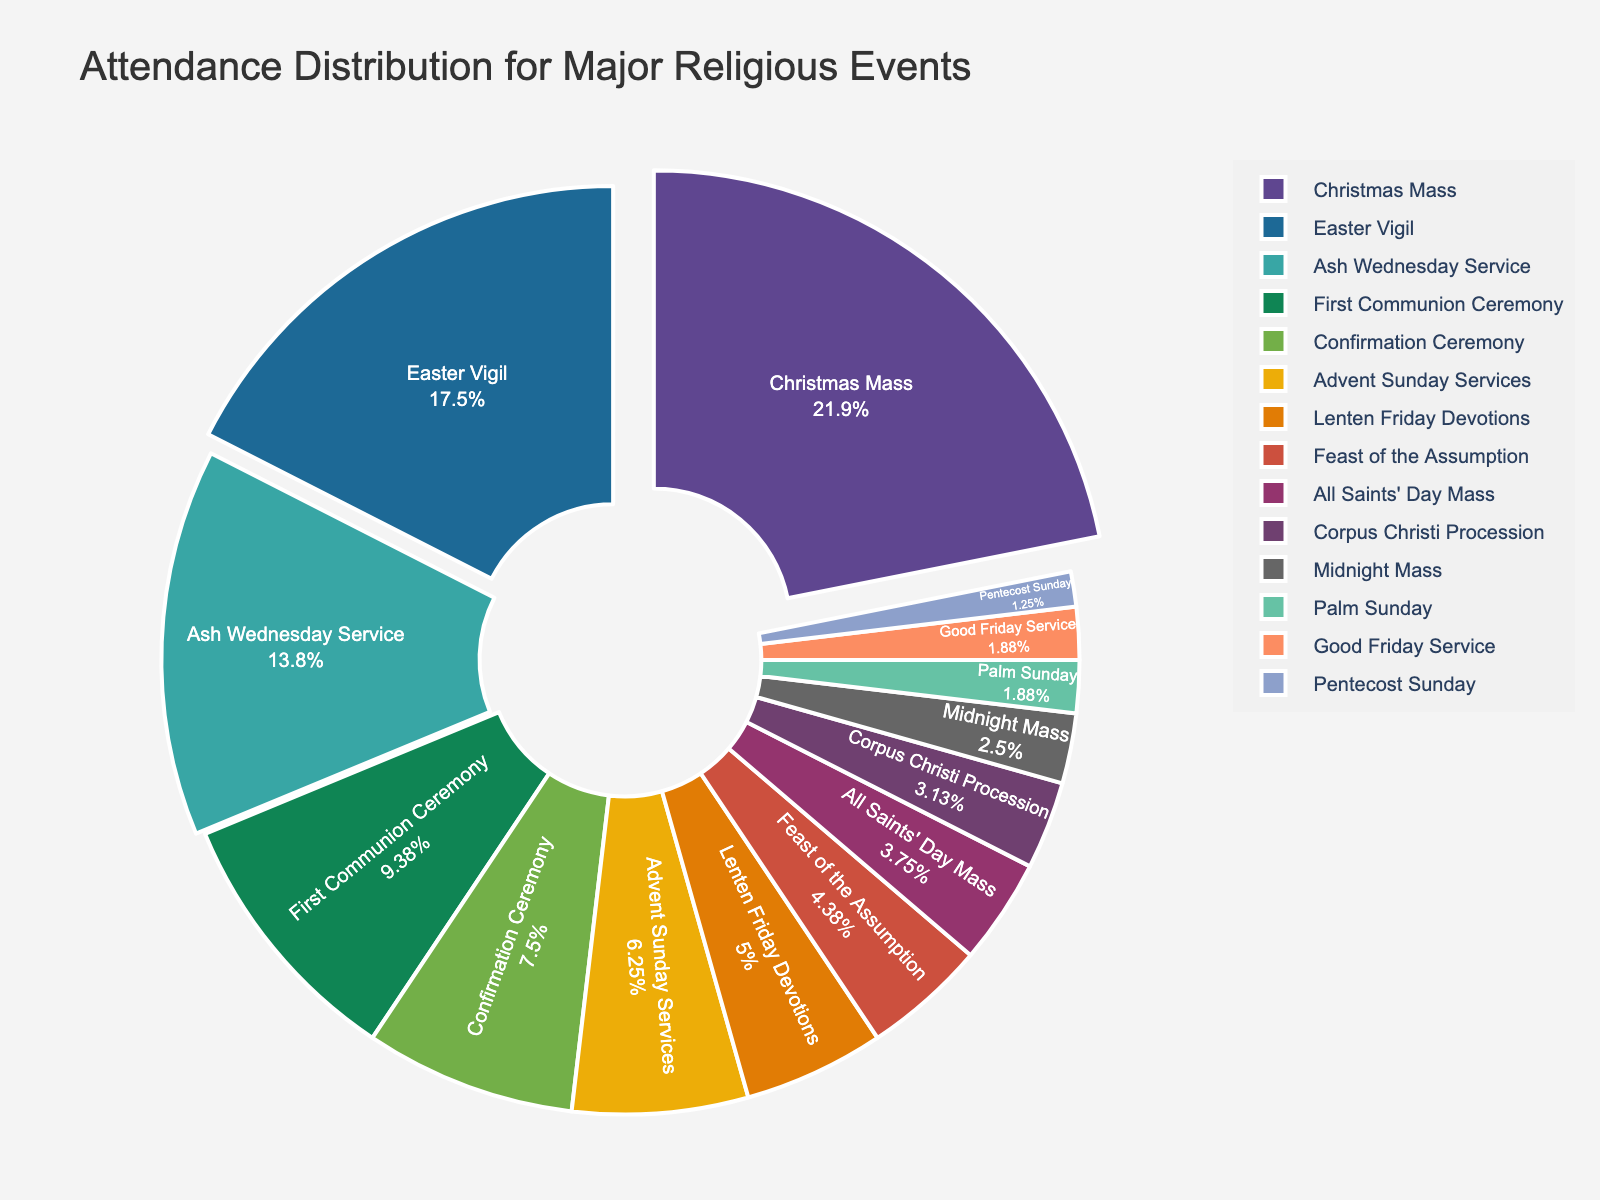What percentage of the total attendance does Christmas Mass have? The slice labeled "Christmas Mass" shows the percentage of total attendance directly inside it.
Answer: Approximately 23.3% Which event has the second highest attendance and what is its percentage share? The slice labeled "Easter Vigil" is the second largest in size, showing its percentage of total attendance inside it.
Answer: Easter Vigil, approximately 18.7% How does the attendance for Easter Vigil compare to Ash Wednesday Service? By comparing the respective slices, we can see that Easter Vigil's slice is larger than Ash Wednesday Service's, indicating higher attendance.
Answer: Easter Vigil > Ash Wednesday Service What is the total attendance for both the Confirmation Ceremony and First Communion Ceremony combined? The slices for Confirmation Ceremony (12 attendees) and First Communion Ceremony (15 attendees) show their respective numbers. Adding them gives the total. 12 + 15 = 27
Answer: 27 Which events have less than 5% share of the attendance? By looking at the slices, we see that events with smaller slices like Midnight Mass, Palm Sunday, Good Friday Service, and Pentecost Sunday have less than 5% each.
Answer: Midnight Mass, Palm Sunday, Good Friday Service, Pentecost Sunday How many times does the attendance of the top event exceed that of the event with the lowest attendance? Christmas Mass has 35 attendees and Pentecost Sunday has 2. We divide 35 by 2 to find how many times more the top attendance is compared to the lowest. 35 / 2 = 17.5
Answer: 17.5 times What is the combined percentage of attendance for the Advent Sunday Services and Lenten Friday Devotions? The slices for Advent Sunday Services and Lenten Friday Devotions show their percentages of total attendance. Summing these gives the combined percentage. 6.7% + 5.3% = 12%
Answer: 12% Which event's slice color is the lightest color shade? The visual inspection of the pie chart indicates the lightest shade usually corresponds to a specific slice. We assume it to be one of the smaller events; inspecting color directly answers this.
Answer: Dependent on actual chart rendering (hypothetically Pentecost Sunday) Which events are highlighted or pulled out in the pie chart? The visual cues show certain slices pulled out to highlight them. These likely correspond to the top three events in attendance (Christmas Mass, Easter Vigil, and Ash Wednesday Service).
Answer: Christmas Mass, Easter Vigil, Ash Wednesday Service 